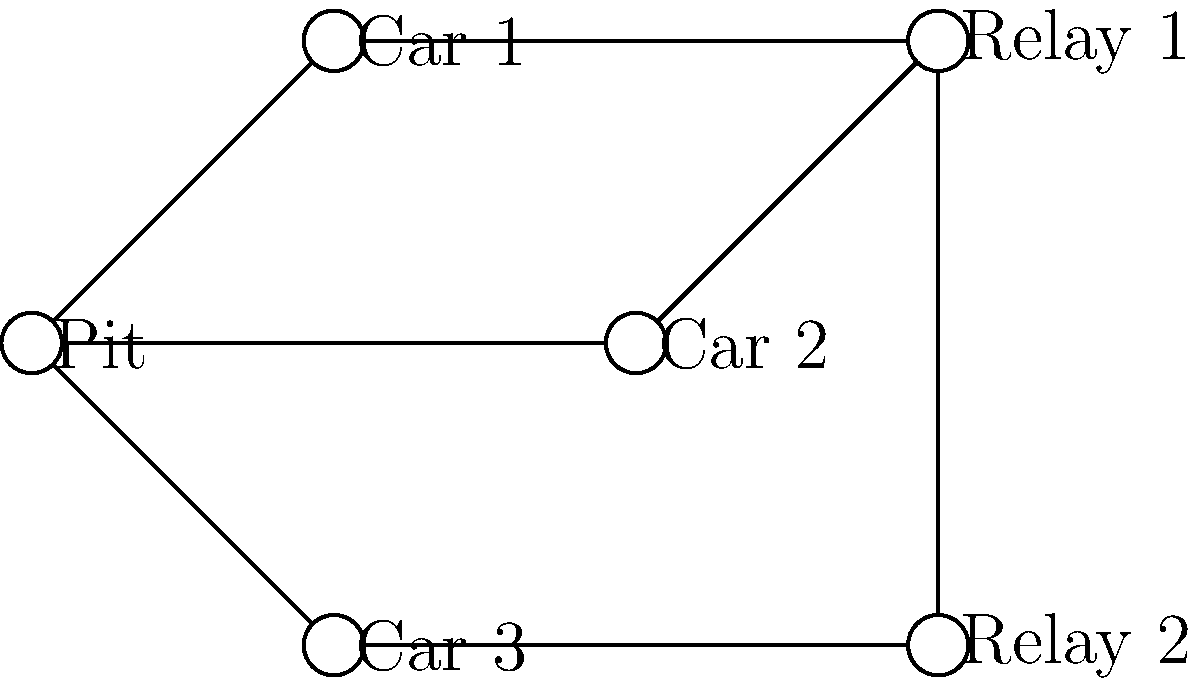In a racing team's communication network, the pit crew needs to send a message to all three cars. Given the network topology shown, what is the minimum number of transmissions required for the message to reach all cars, assuming each node can only transmit to its directly connected neighbors? To determine the minimum number of transmissions, let's analyze the network topology step-by-step:

1. The pit crew (Pit) is directly connected to all three cars (Car 1, Car 2, and Car 3).

2. However, the question asks for the minimum number of transmissions, so we need to consider if there's a more efficient way to reach all cars.

3. We can see that Car 1 and Car 2 are connected to Relay 1, while Car 3 is connected to Relay 2.

4. Relay 1 and Relay 2 are connected to each other.

5. The most efficient path would be:
   a. Pit transmits to Relay 1 (1 transmission)
   b. Relay 1 transmits to Car 1 and Car 2 simultaneously (1 transmission)
   c. Relay 1 transmits to Relay 2 (1 transmission)
   d. Relay 2 transmits to Car 3 (1 transmission)

6. This approach requires a total of 4 transmissions to reach all three cars.

7. Any other method (such as Pit transmitting directly to each car) would require more transmissions.

Therefore, the minimum number of transmissions required is 4.
Answer: 4 transmissions 